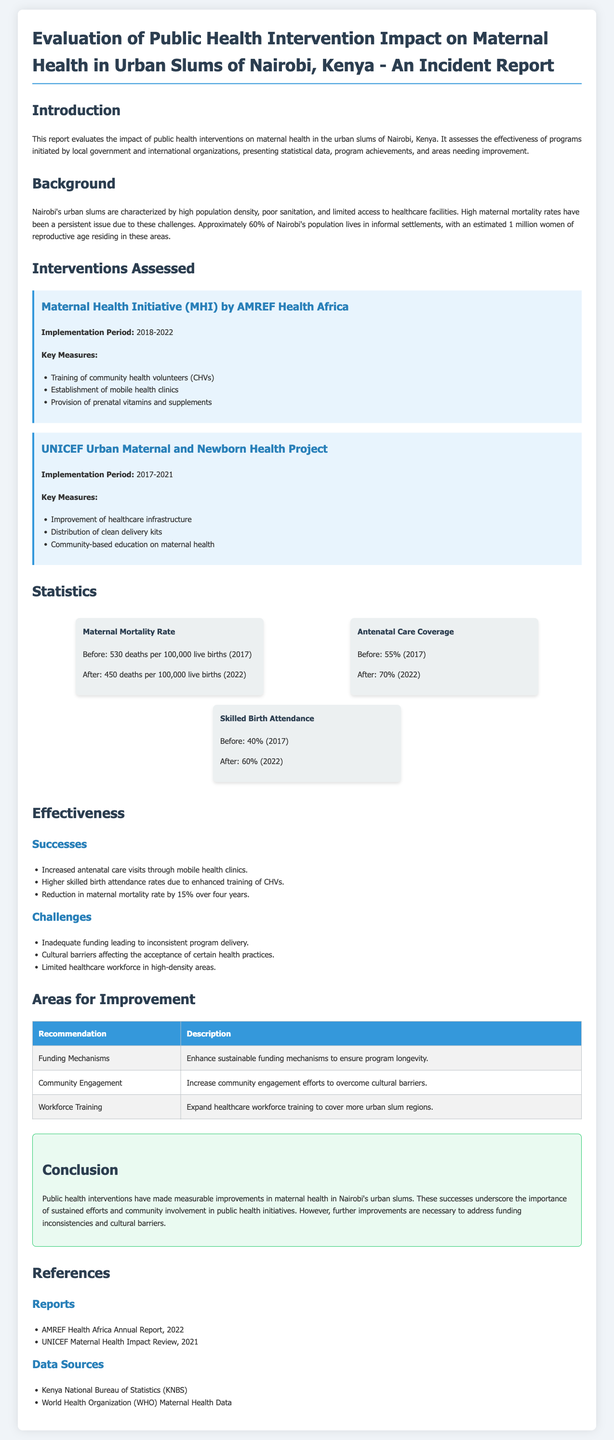What is the implementation period of the Maternal Health Initiative? The implementation period for the Maternal Health Initiative by AMREF Health Africa is specified in the document as 2018-2022.
Answer: 2018-2022 What was the maternal mortality rate before the interventions? The document provides the maternal mortality rate before the interventions was 530 deaths per 100,000 live births in 2017.
Answer: 530 deaths per 100,000 live births What is the percentage increase in antenatal care coverage? The difference in antenatal care coverage before (55%) and after (70%) provides the percentage increase of 15%.
Answer: 15% Which organization conducted the Urban Maternal and Newborn Health Project? The report mentions that UNICEF conducted the Urban Maternal and Newborn Health Project.
Answer: UNICEF What is one of the key measures of the UNICEF project? The report lists 'Distribution of clean delivery kits' as one of the key measures of the UNICEF project.
Answer: Distribution of clean delivery kits What recommendation is made to enhance program longevity? The recommendation made in the document is to enhance sustainable funding mechanisms.
Answer: Enhance sustainable funding mechanisms What was the change in skilled birth attendance rates? The document states that skilled birth attendance rates increased from 40% to 60%, showing a 20% rise.
Answer: 20% What is a challenge mentioned in the report? The report highlights 'Inadequate funding leading to inconsistent program delivery' as one of the challenges faced.
Answer: Inadequate funding leading to inconsistent program delivery What conclusion is drawn about public health interventions? The conclusion drawn in the report states that public health interventions have made measurable improvements in maternal health.
Answer: Measurable improvements in maternal health 